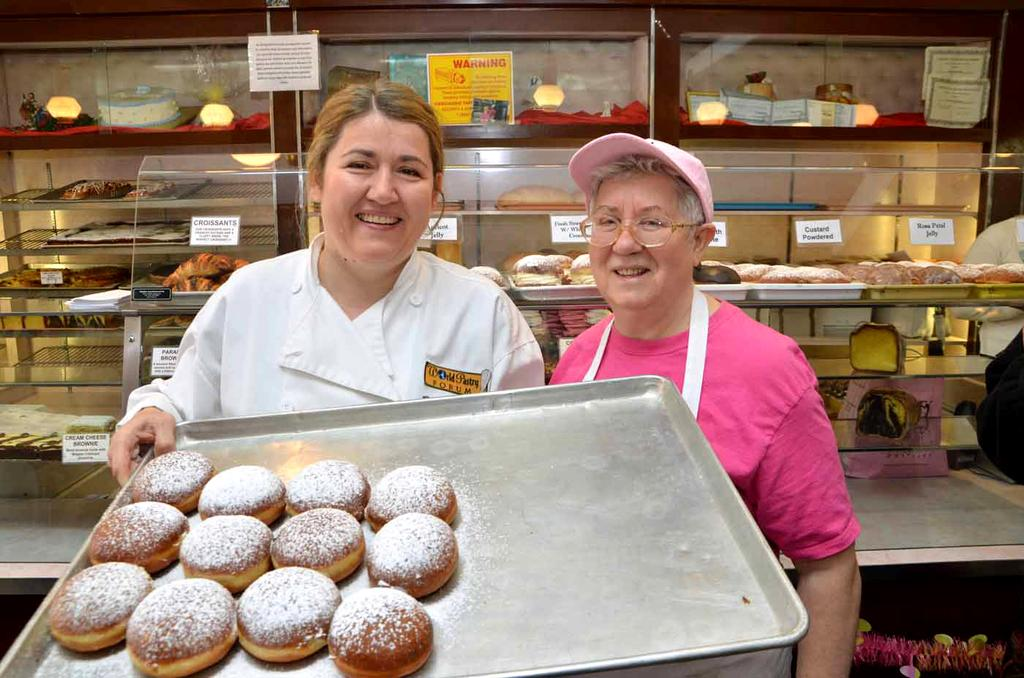How many women are present in the image? There are two women in the image. What is one of the women holding in the image? One woman is holding a tray with cookies. Can you describe the tray with cookies in the image? The tray with cookies is visible in the image. What else related to cookies can be seen in the background of the image? There are racks with cookies in the background of the image. Are the racks with cookies visible in the image? Yes, the racks with cookies are visible in the image. What language are the cookies speaking in the image? Cookies do not speak a language, as they are inanimate objects. 